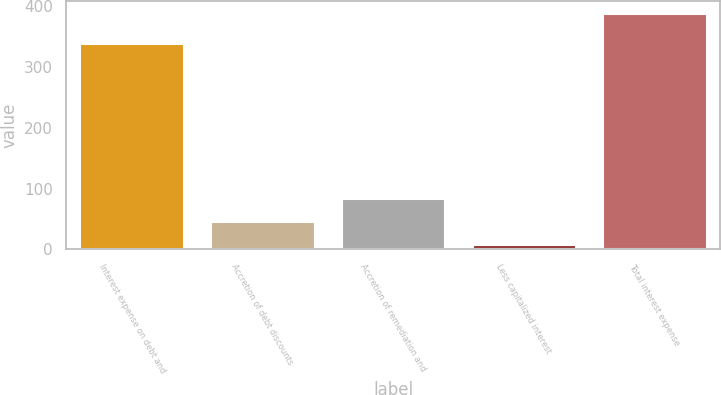Convert chart to OTSL. <chart><loc_0><loc_0><loc_500><loc_500><bar_chart><fcel>Interest expense on debt and<fcel>Accretion of debt discounts<fcel>Accretion of remediation and<fcel>Less capitalized interest<fcel>Total interest expense<nl><fcel>338.5<fcel>46.41<fcel>84.42<fcel>8.4<fcel>388.5<nl></chart> 